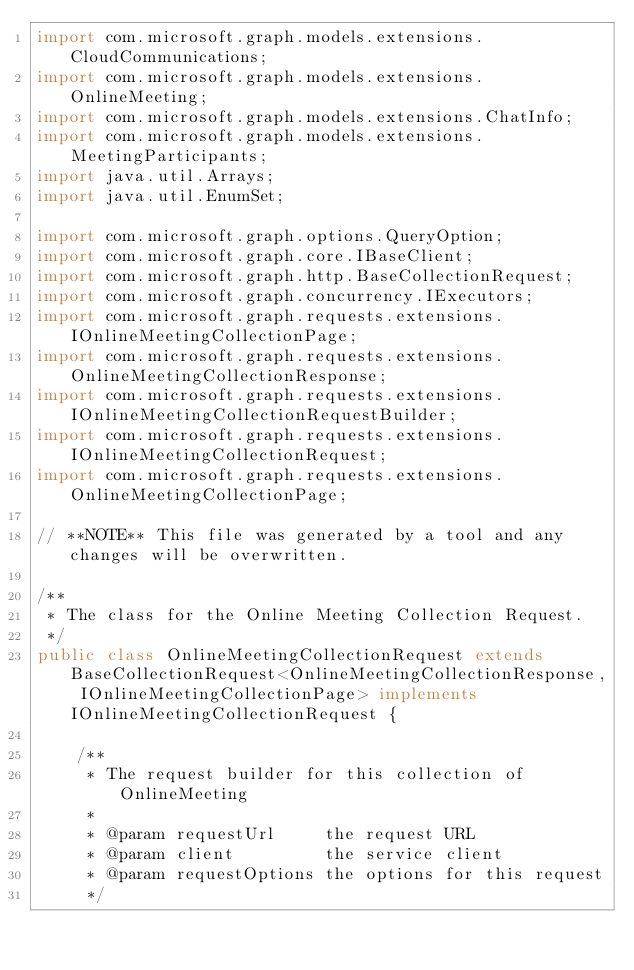Convert code to text. <code><loc_0><loc_0><loc_500><loc_500><_Java_>import com.microsoft.graph.models.extensions.CloudCommunications;
import com.microsoft.graph.models.extensions.OnlineMeeting;
import com.microsoft.graph.models.extensions.ChatInfo;
import com.microsoft.graph.models.extensions.MeetingParticipants;
import java.util.Arrays;
import java.util.EnumSet;

import com.microsoft.graph.options.QueryOption;
import com.microsoft.graph.core.IBaseClient;
import com.microsoft.graph.http.BaseCollectionRequest;
import com.microsoft.graph.concurrency.IExecutors;
import com.microsoft.graph.requests.extensions.IOnlineMeetingCollectionPage;
import com.microsoft.graph.requests.extensions.OnlineMeetingCollectionResponse;
import com.microsoft.graph.requests.extensions.IOnlineMeetingCollectionRequestBuilder;
import com.microsoft.graph.requests.extensions.IOnlineMeetingCollectionRequest;
import com.microsoft.graph.requests.extensions.OnlineMeetingCollectionPage;

// **NOTE** This file was generated by a tool and any changes will be overwritten.

/**
 * The class for the Online Meeting Collection Request.
 */
public class OnlineMeetingCollectionRequest extends BaseCollectionRequest<OnlineMeetingCollectionResponse, IOnlineMeetingCollectionPage> implements IOnlineMeetingCollectionRequest {

    /**
     * The request builder for this collection of OnlineMeeting
     *
     * @param requestUrl     the request URL
     * @param client         the service client
     * @param requestOptions the options for this request
     */</code> 